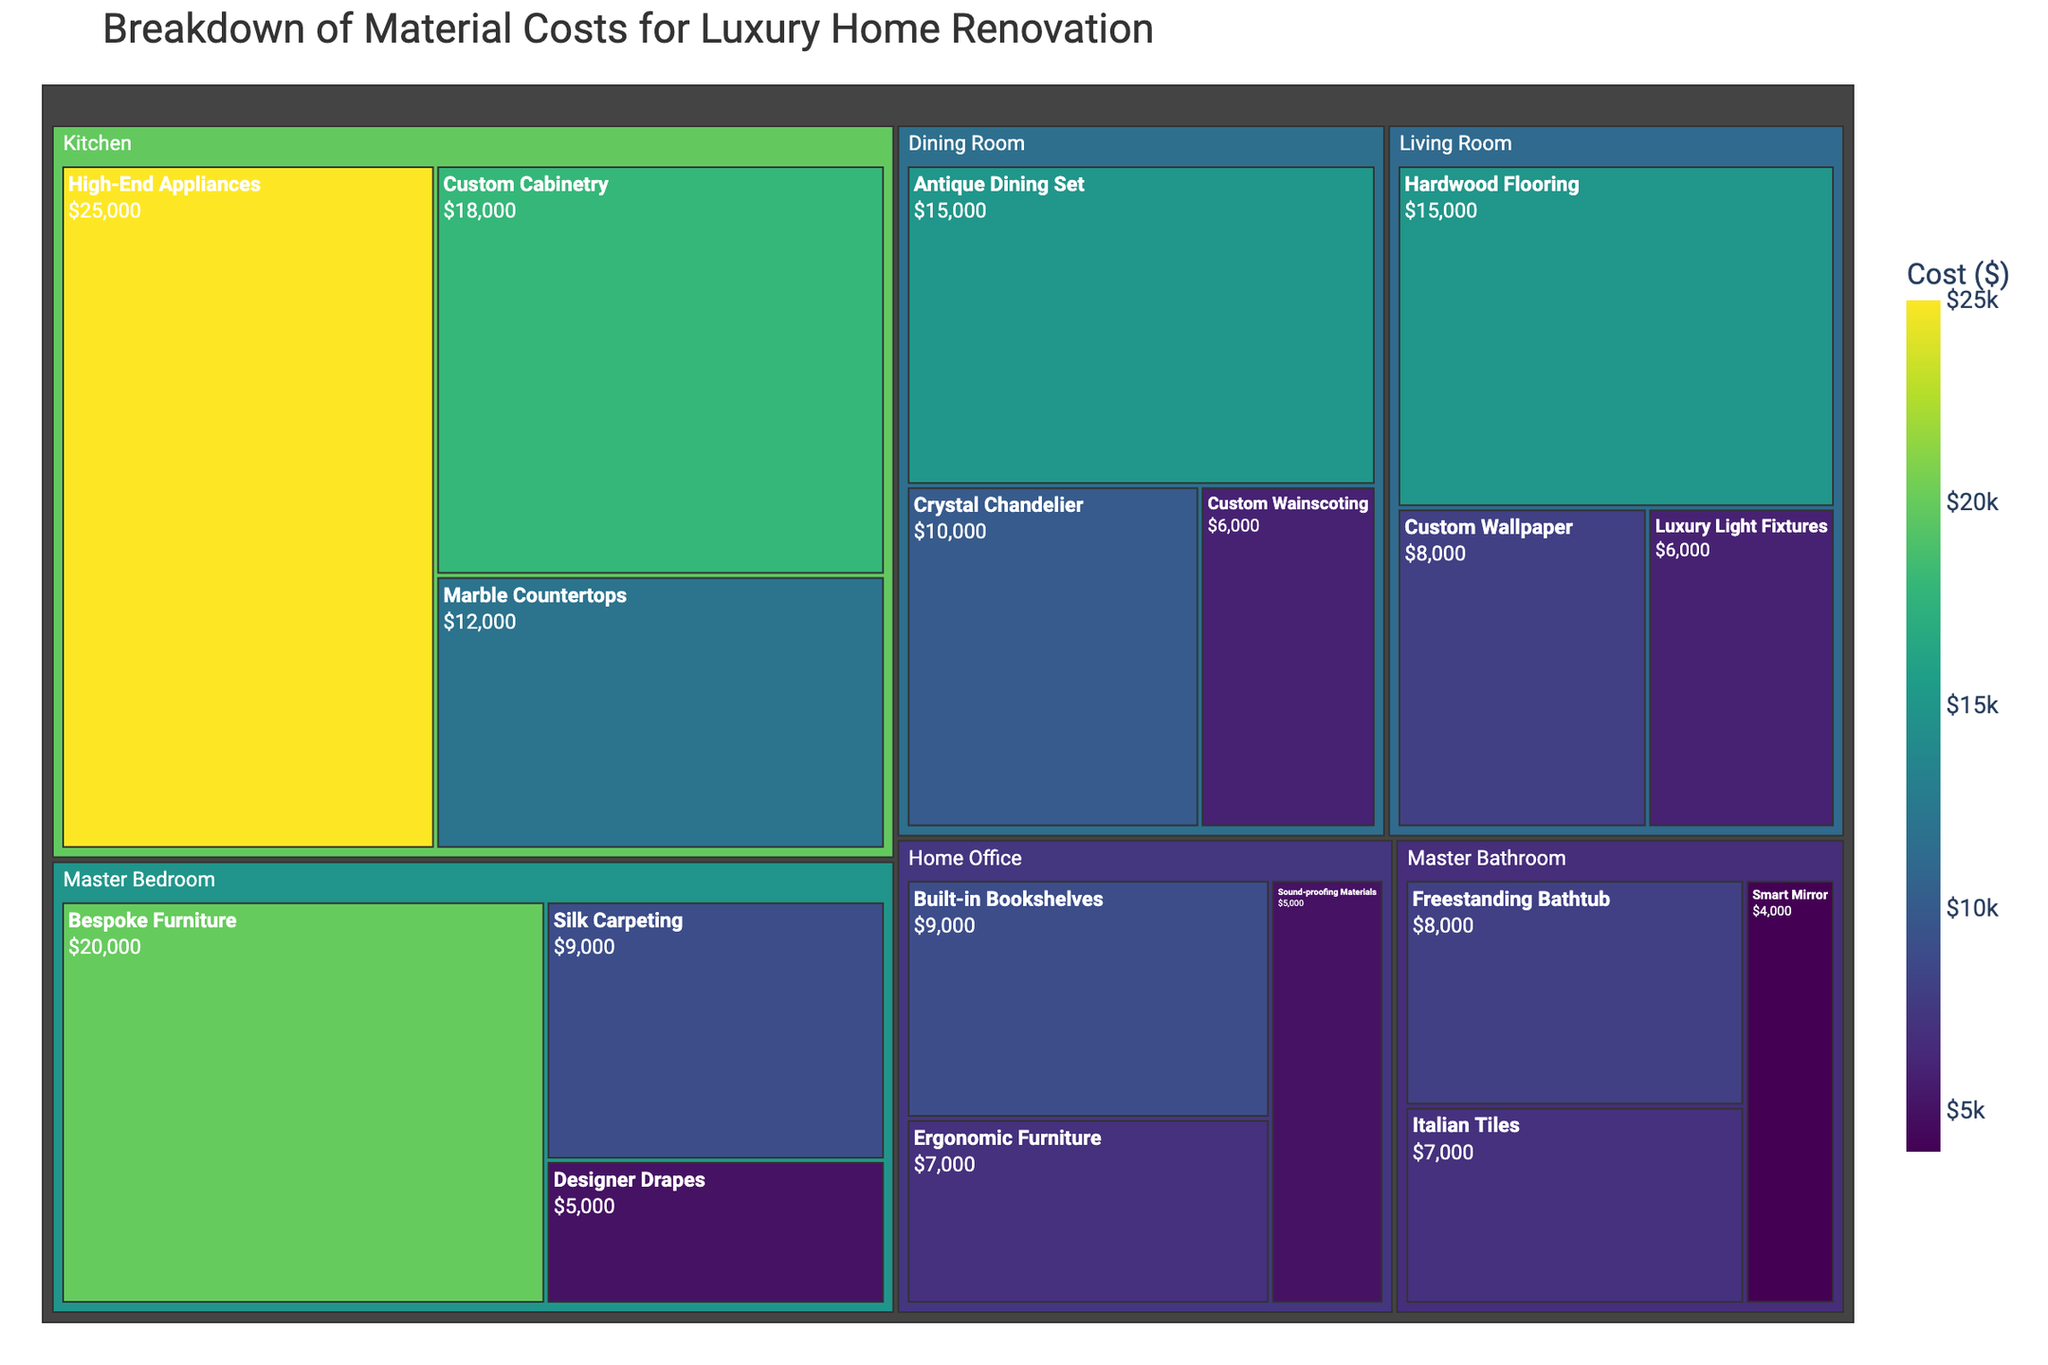What's the title of the treemap? The title is displayed at the top of the treemap and indicates the focus of the visualization.
Answer: Breakdown of Material Costs for Luxury Home Renovation Which room has the highest cost material? To find this, identify the largest segment in terms of color intensity and area under the specified room.
Answer: Kitchen What's the total cost of materials for the Living Room? Sum up the costs of all materials listed under the Living Room. $15,000 (Hardwood Flooring) + $8,000 (Custom Wallpaper) + $6,000 (Luxury Light Fixtures) = $29,000.
Answer: $29,000 Compare the cost of Custom Cabinetry in the Kitchen with the cost of Crystal Chandelier in the Dining Room. Which one is higher? Identify both items in their respective rooms and compare their costs. Custom Cabinetry ($18,000) is more expensive than the Crystal Chandelier ($10,000).
Answer: Custom Cabinetry What's the cost difference between the most and least expensive materials in the Master Bedroom? Locate the most and least expensive materials in the Master Bedroom and calculate the difference. $20,000 (Bespoke Furniture) - $5,000 (Designer Drapes) = $15,000.
Answer: $15,000 Which material type in the Home Office has the lowest cost? Identify and compare the costs of all materials listed under the Home Office.
Answer: Sound-proofing Materials What's the total cost for all materials in the Master Bathroom? Add up the costs of all materials listed under the Master Bathroom. $7,000 (Italian Tiles) + $8,000 (Freestanding Bathtub) + $4,000 (Smart Mirror) = $19,000.
Answer: $19,000 How does the cost of High-End Appliances in the Kitchen compare to the cost of Bespoke Furniture in the Master Bedroom? Compare the costs listed for High-End Appliances ($25,000) and Bespoke Furniture ($20,000). The High-End Appliances are more expensive.
Answer: High-End Appliances What is the most expensive material type, and in which room is it located? Identify the material with the highest cost value and note its associated room. High-End Appliances in the Kitchen is the most expensive material type.
Answer: High-End Appliances in the Kitchen Which room has the most diversified material types in terms of the number of different materials purchased? Count and compare the number of different materials listed under each room. The Kitchen and Master Bedroom both have 3 different material types, the highest number among all rooms.
Answer: Kitchen and Master Bedroom 